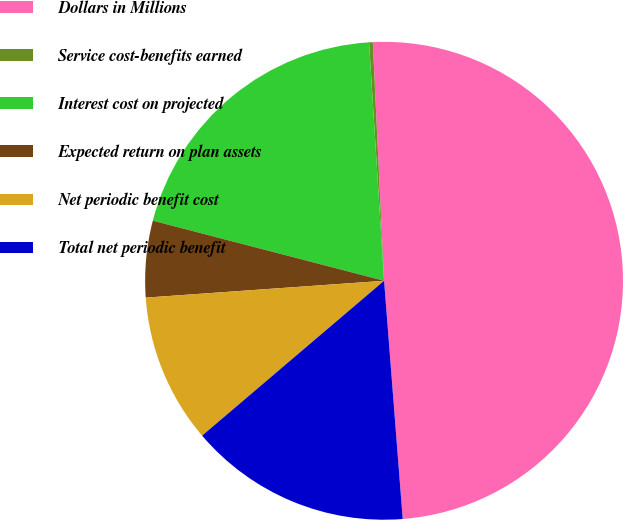Convert chart to OTSL. <chart><loc_0><loc_0><loc_500><loc_500><pie_chart><fcel>Dollars in Millions<fcel>Service cost-benefits earned<fcel>Interest cost on projected<fcel>Expected return on plan assets<fcel>Net periodic benefit cost<fcel>Total net periodic benefit<nl><fcel>49.51%<fcel>0.25%<fcel>19.95%<fcel>5.17%<fcel>10.1%<fcel>15.02%<nl></chart> 